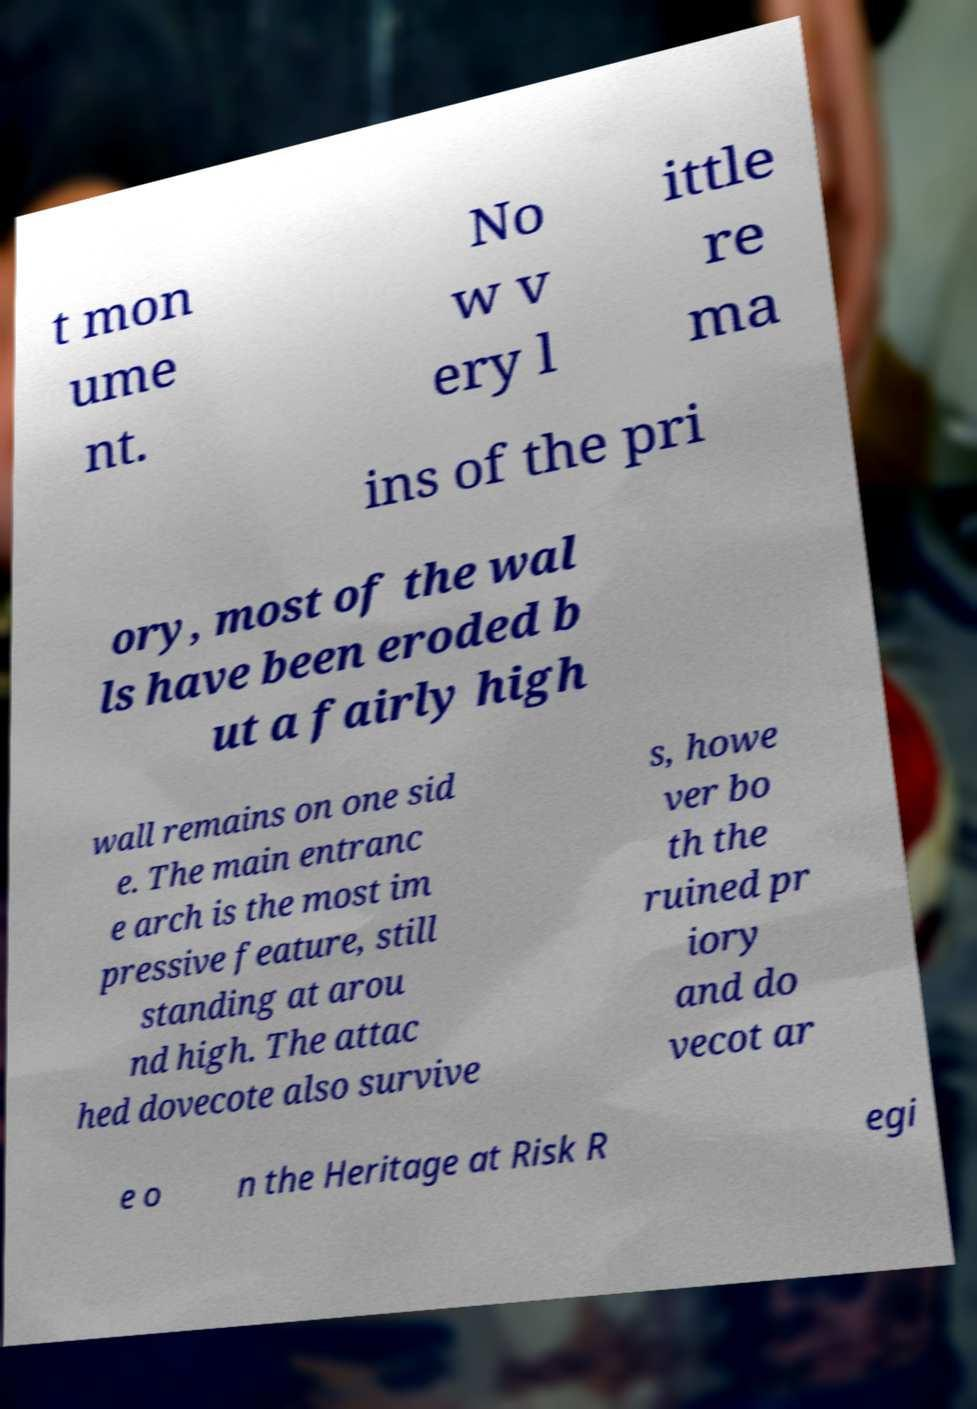Can you accurately transcribe the text from the provided image for me? t mon ume nt. No w v ery l ittle re ma ins of the pri ory, most of the wal ls have been eroded b ut a fairly high wall remains on one sid e. The main entranc e arch is the most im pressive feature, still standing at arou nd high. The attac hed dovecote also survive s, howe ver bo th the ruined pr iory and do vecot ar e o n the Heritage at Risk R egi 